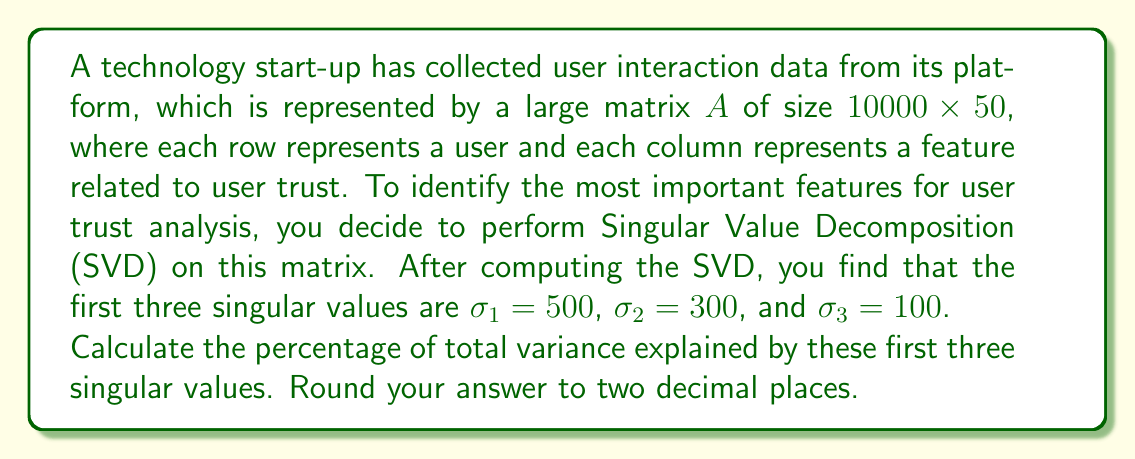Can you solve this math problem? To solve this problem, we'll follow these steps:

1) Recall that in SVD, a matrix $A$ is decomposed as $A = U\Sigma V^T$, where $\Sigma$ is a diagonal matrix containing the singular values.

2) The total variance in the data is equal to the sum of squares of all singular values.

3) The variance explained by each singular value is proportional to the square of that singular value.

4) We don't know all the singular values, but we can calculate the percentage explained by the first three without knowing the others.

5) Let's call the sum of squares of all singular values $S$. Then:

   $S = \sigma_1^2 + \sigma_2^2 + \sigma_3^2 + ... + \sigma_{50}^2$

6) The variance explained by the first three singular values is:

   $V_3 = \sigma_1^2 + \sigma_2^2 + \sigma_3^2$

7) Calculate $V_3$:
   
   $V_3 = 500^2 + 300^2 + 100^2 = 250000 + 90000 + 10000 = 350000$

8) The percentage of variance explained is:

   $\text{Percentage} = \frac{V_3}{S} \times 100\%$

9) We don't know $S$, but we know that $S \geq V_3$ (because all singular values are non-negative).

10) Therefore, the maximum possible percentage is:

    $\text{Max Percentage} = \frac{V_3}{V_3} \times 100\% = 100\%$

11) The actual percentage will be less than or equal to this maximum.
Answer: The percentage of total variance explained by the first three singular values is at most 100.00%. 